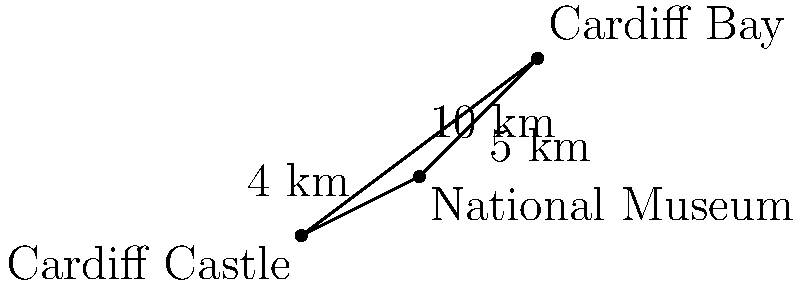You're planning a trip to Cardiff and want to visit three landmarks: Cardiff Castle, Cardiff Bay, and the National Museum. The distances between these locations form a triangle as shown in the diagram. If you're at Cardiff Castle and want to visit both the National Museum and Cardiff Bay, what's the shortest total distance you'll need to walk? (Assume you can walk in straight lines between locations.) Let's approach this step-by-step:

1) We're given a triangle with the following sides:
   - Cardiff Castle to Cardiff Bay: 10 km
   - Cardiff Bay to National Museum: 5 km
   - National Museum to Cardiff Castle: 4 km

2) We need to find the shortest path from Cardiff Castle to both other locations.

3) There are two possible routes:
   a) Castle → Museum → Bay
   b) Castle → Bay → Museum

4) Route a: Castle → Museum → Bay
   Distance = 4 km + 5 km = 9 km

5) Route b: Castle → Bay → Museum
   Distance = 10 km + 5 km = 15 km

6) Clearly, route a is shorter.

7) Therefore, the shortest total distance is 9 km.

This problem demonstrates the triangle inequality theorem, which states that the sum of the lengths of any two sides of a triangle must be greater than the length of the remaining side. In this case, going directly to the Bay (10 km) is longer than going via the Museum (4 km + 5 km = 9 km).
Answer: 9 km 